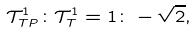Convert formula to latex. <formula><loc_0><loc_0><loc_500><loc_500>\mathcal { T } _ { T P } ^ { 1 } \colon \mathcal { T } _ { T } ^ { 1 } = 1 \colon - \sqrt { 2 } ,</formula> 